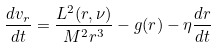Convert formula to latex. <formula><loc_0><loc_0><loc_500><loc_500>\frac { d v _ { r } } { d t } = \frac { L ^ { 2 } ( r , \nu ) } { M ^ { 2 } r ^ { 3 } } - g ( r ) - \eta \frac { d r } { d t }</formula> 